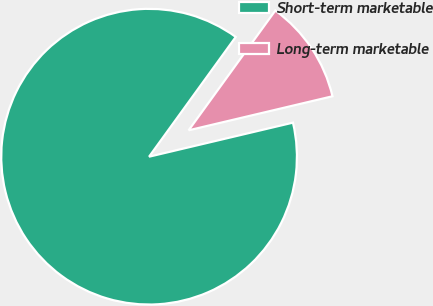<chart> <loc_0><loc_0><loc_500><loc_500><pie_chart><fcel>Short-term marketable<fcel>Long-term marketable<nl><fcel>88.67%<fcel>11.33%<nl></chart> 